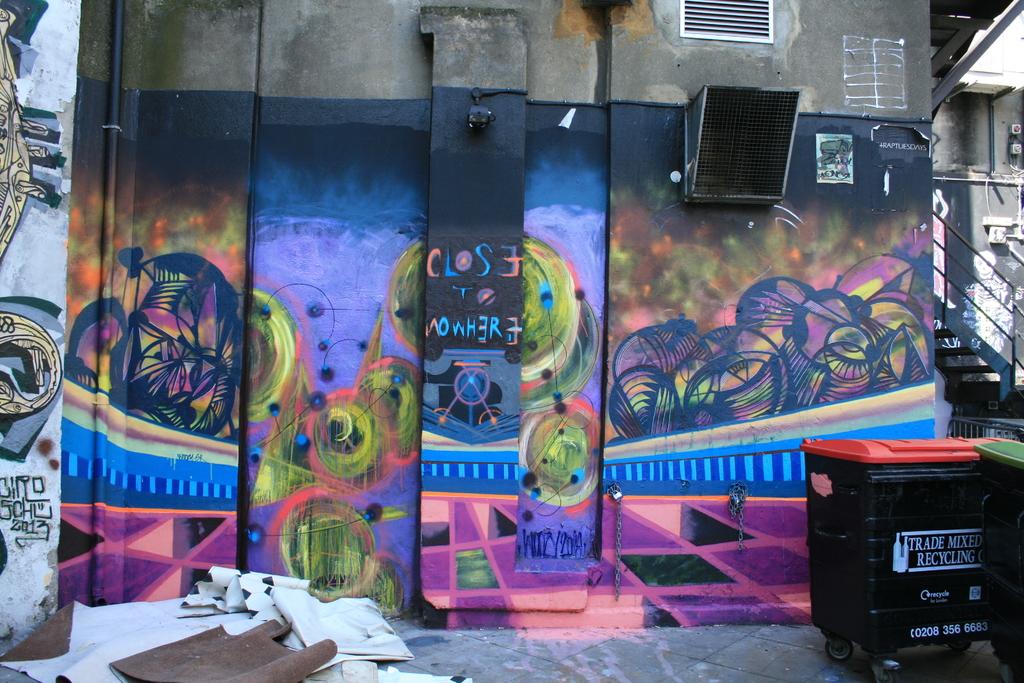What does the bin with the red top say on it?
Provide a short and direct response. Trade mixed recycling. 